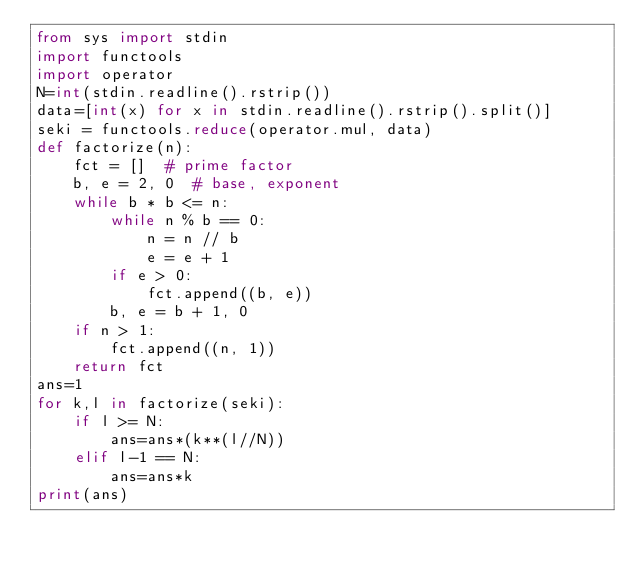<code> <loc_0><loc_0><loc_500><loc_500><_Python_>from sys import stdin
import functools
import operator
N=int(stdin.readline().rstrip())
data=[int(x) for x in stdin.readline().rstrip().split()]
seki = functools.reduce(operator.mul, data)
def factorize(n):
    fct = []  # prime factor
    b, e = 2, 0  # base, exponent
    while b * b <= n:
        while n % b == 0:
            n = n // b
            e = e + 1
        if e > 0:
            fct.append((b, e))
        b, e = b + 1, 0
    if n > 1:
        fct.append((n, 1))
    return fct
ans=1
for k,l in factorize(seki):
    if l >= N:
        ans=ans*(k**(l//N))
    elif l-1 == N:
        ans=ans*k
print(ans)</code> 